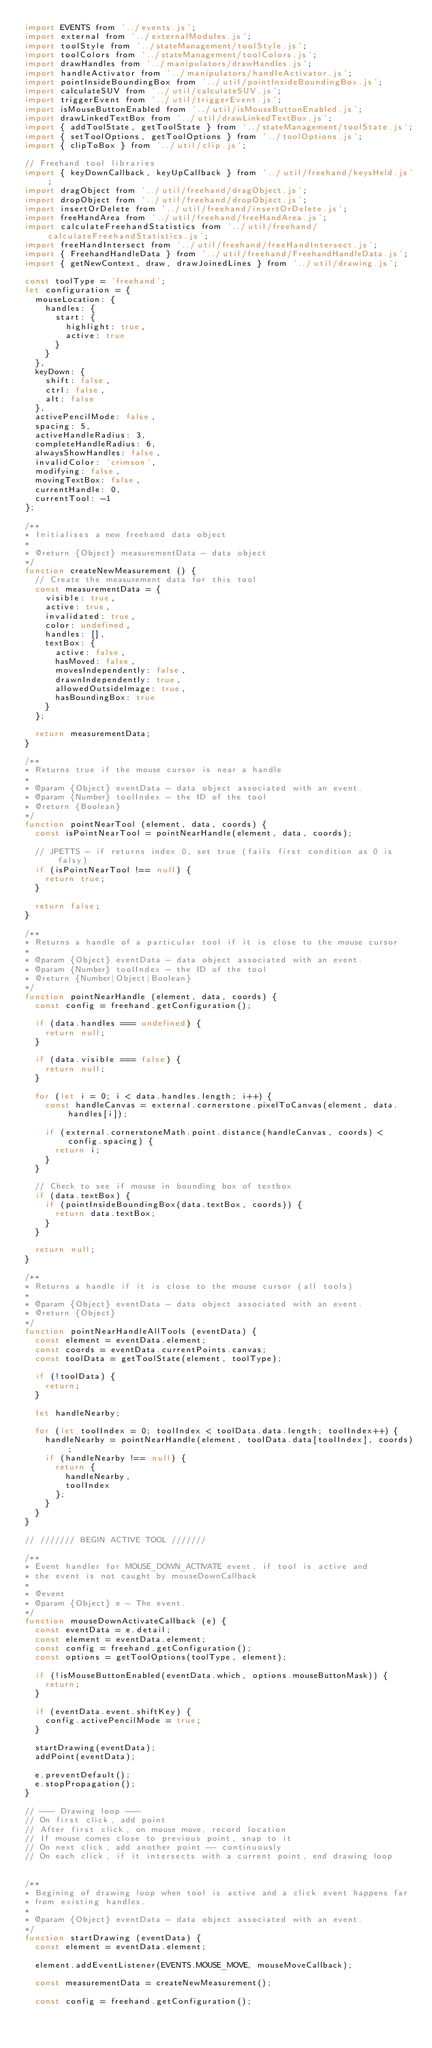Convert code to text. <code><loc_0><loc_0><loc_500><loc_500><_JavaScript_>import EVENTS from '../events.js';
import external from '../externalModules.js';
import toolStyle from '../stateManagement/toolStyle.js';
import toolColors from '../stateManagement/toolColors.js';
import drawHandles from '../manipulators/drawHandles.js';
import handleActivator from '../manipulators/handleActivator.js';
import pointInsideBoundingBox from '../util/pointInsideBoundingBox.js';
import calculateSUV from '../util/calculateSUV.js';
import triggerEvent from '../util/triggerEvent.js';
import isMouseButtonEnabled from '../util/isMouseButtonEnabled.js';
import drawLinkedTextBox from '../util/drawLinkedTextBox.js';
import { addToolState, getToolState } from '../stateManagement/toolState.js';
import { setToolOptions, getToolOptions } from '../toolOptions.js';
import { clipToBox } from '../util/clip.js';

// Freehand tool libraries
import { keyDownCallback, keyUpCallback } from '../util/freehand/keysHeld.js';
import dragObject from '../util/freehand/dragObject.js';
import dropObject from '../util/freehand/dropObject.js';
import insertOrDelete from '../util/freehand/insertOrDelete.js';
import freeHandArea from '../util/freehand/freeHandArea.js';
import calculateFreehandStatistics from '../util/freehand/calculateFreehandStatistics.js';
import freeHandIntersect from '../util/freehand/freeHandIntersect.js';
import { FreehandHandleData } from '../util/freehand/FreehandHandleData.js';
import { getNewContext, draw, drawJoinedLines } from '../util/drawing.js';

const toolType = 'freehand';
let configuration = {
  mouseLocation: {
    handles: {
      start: {
        highlight: true,
        active: true
      }
    }
  },
  keyDown: {
    shift: false,
    ctrl: false,
    alt: false
  },
  activePencilMode: false,
  spacing: 5,
  activeHandleRadius: 3,
  completeHandleRadius: 6,
  alwaysShowHandles: false,
  invalidColor: 'crimson',
  modifying: false,
  movingTextBox: false,
  currentHandle: 0,
  currentTool: -1
};

/**
* Initialises a new freehand data object
*
* @return {Object} measurementData - data object
*/
function createNewMeasurement () {
  // Create the measurement data for this tool
  const measurementData = {
    visible: true,
    active: true,
    invalidated: true,
    color: undefined,
    handles: [],
    textBox: {
      active: false,
      hasMoved: false,
      movesIndependently: false,
      drawnIndependently: true,
      allowedOutsideImage: true,
      hasBoundingBox: true
    }
  };

  return measurementData;
}

/**
* Returns true if the mouse cursor is near a handle
*
* @param {Object} eventData - data object associated with an event.
* @param {Number} toolIndex - the ID of the tool
* @return {Boolean}
*/
function pointNearTool (element, data, coords) {
  const isPointNearTool = pointNearHandle(element, data, coords);

  // JPETTS - if returns index 0, set true (fails first condition as 0 is falsy).
  if (isPointNearTool !== null) {
    return true;
  }

  return false;
}

/**
* Returns a handle of a particular tool if it is close to the mouse cursor
*
* @param {Object} eventData - data object associated with an event.
* @param {Number} toolIndex - the ID of the tool
* @return {Number|Object|Boolean}
*/
function pointNearHandle (element, data, coords) {
  const config = freehand.getConfiguration();

  if (data.handles === undefined) {
    return null;
  }

  if (data.visible === false) {
    return null;
  }

  for (let i = 0; i < data.handles.length; i++) {
    const handleCanvas = external.cornerstone.pixelToCanvas(element, data.handles[i]);

    if (external.cornerstoneMath.point.distance(handleCanvas, coords) < config.spacing) {
      return i;
    }
  }

  // Check to see if mouse in bounding box of textbox
  if (data.textBox) {
    if (pointInsideBoundingBox(data.textBox, coords)) {
      return data.textBox;
    }
  }

  return null;
}

/**
* Returns a handle if it is close to the mouse cursor (all tools)
*
* @param {Object} eventData - data object associated with an event.
* @return {Object}
*/
function pointNearHandleAllTools (eventData) {
  const element = eventData.element;
  const coords = eventData.currentPoints.canvas;
  const toolData = getToolState(element, toolType);

  if (!toolData) {
    return;
  }

  let handleNearby;

  for (let toolIndex = 0; toolIndex < toolData.data.length; toolIndex++) {
    handleNearby = pointNearHandle(element, toolData.data[toolIndex], coords);
    if (handleNearby !== null) {
      return {
        handleNearby,
        toolIndex
      };
    }
  }
}

// /////// BEGIN ACTIVE TOOL ///////

/**
* Event handler for MOUSE_DOWN_ACTIVATE event, if tool is active and
* the event is not caught by mouseDownCallback
*
* @event
* @param {Object} e - The event.
*/
function mouseDownActivateCallback (e) {
  const eventData = e.detail;
  const element = eventData.element;
  const config = freehand.getConfiguration();
  const options = getToolOptions(toolType, element);

  if (!isMouseButtonEnabled(eventData.which, options.mouseButtonMask)) {
    return;
  }

  if (eventData.event.shiftKey) {
    config.activePencilMode = true;
  }

  startDrawing(eventData);
  addPoint(eventData);

  e.preventDefault();
  e.stopPropagation();
}

// --- Drawing loop ---
// On first click, add point
// After first click, on mouse move, record location
// If mouse comes close to previous point, snap to it
// On next click, add another point -- continuously
// On each click, if it intersects with a current point, end drawing loop


/**
* Begining of drawing loop when tool is active and a click event happens far
* from existing handles.
*
* @param {Object} eventData - data object associated with an event.
*/
function startDrawing (eventData) {
  const element = eventData.element;

  element.addEventListener(EVENTS.MOUSE_MOVE, mouseMoveCallback);

  const measurementData = createNewMeasurement();

  const config = freehand.getConfiguration();
</code> 